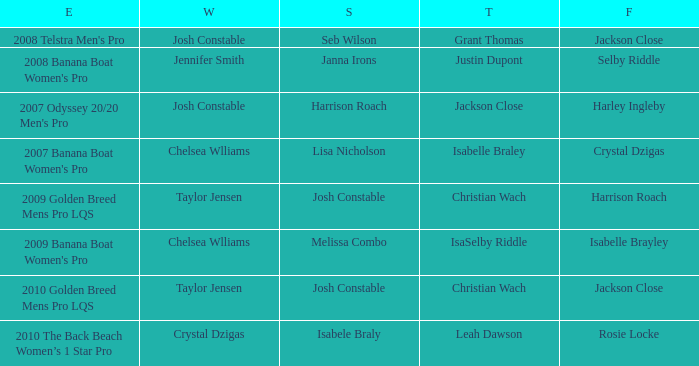Who was in Second Place with Isabelle Brayley came in Fourth? Melissa Combo. 